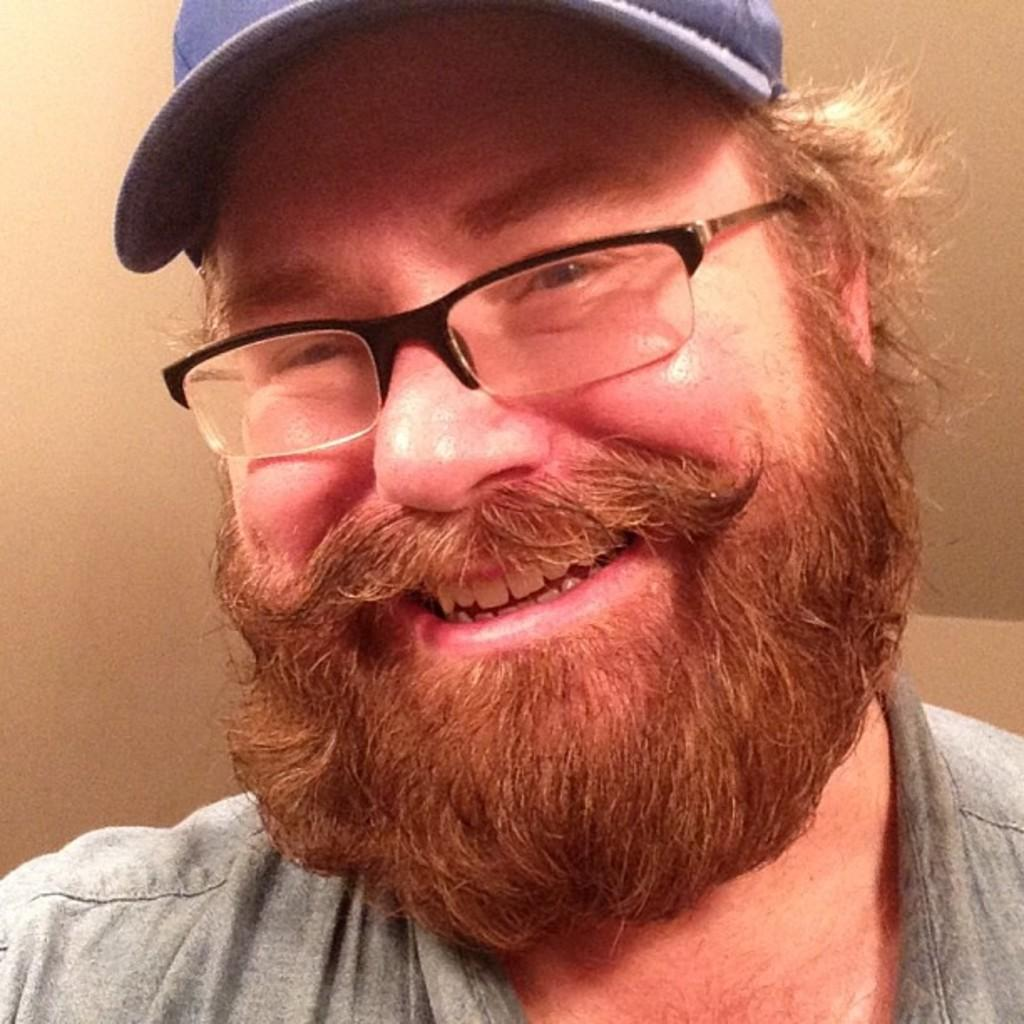What is present in the image? There is a man in the image. What is the man doing in the image? The man is smiling. What accessories is the man wearing in the image? The man is wearing spectacles and a cap. What type of carriage is the man using to transport the crate in the image? There is no carriage or crate present in the image. What is the color of the man's heart in the image? The man's heart is not visible in the image, as it is an internal organ. 